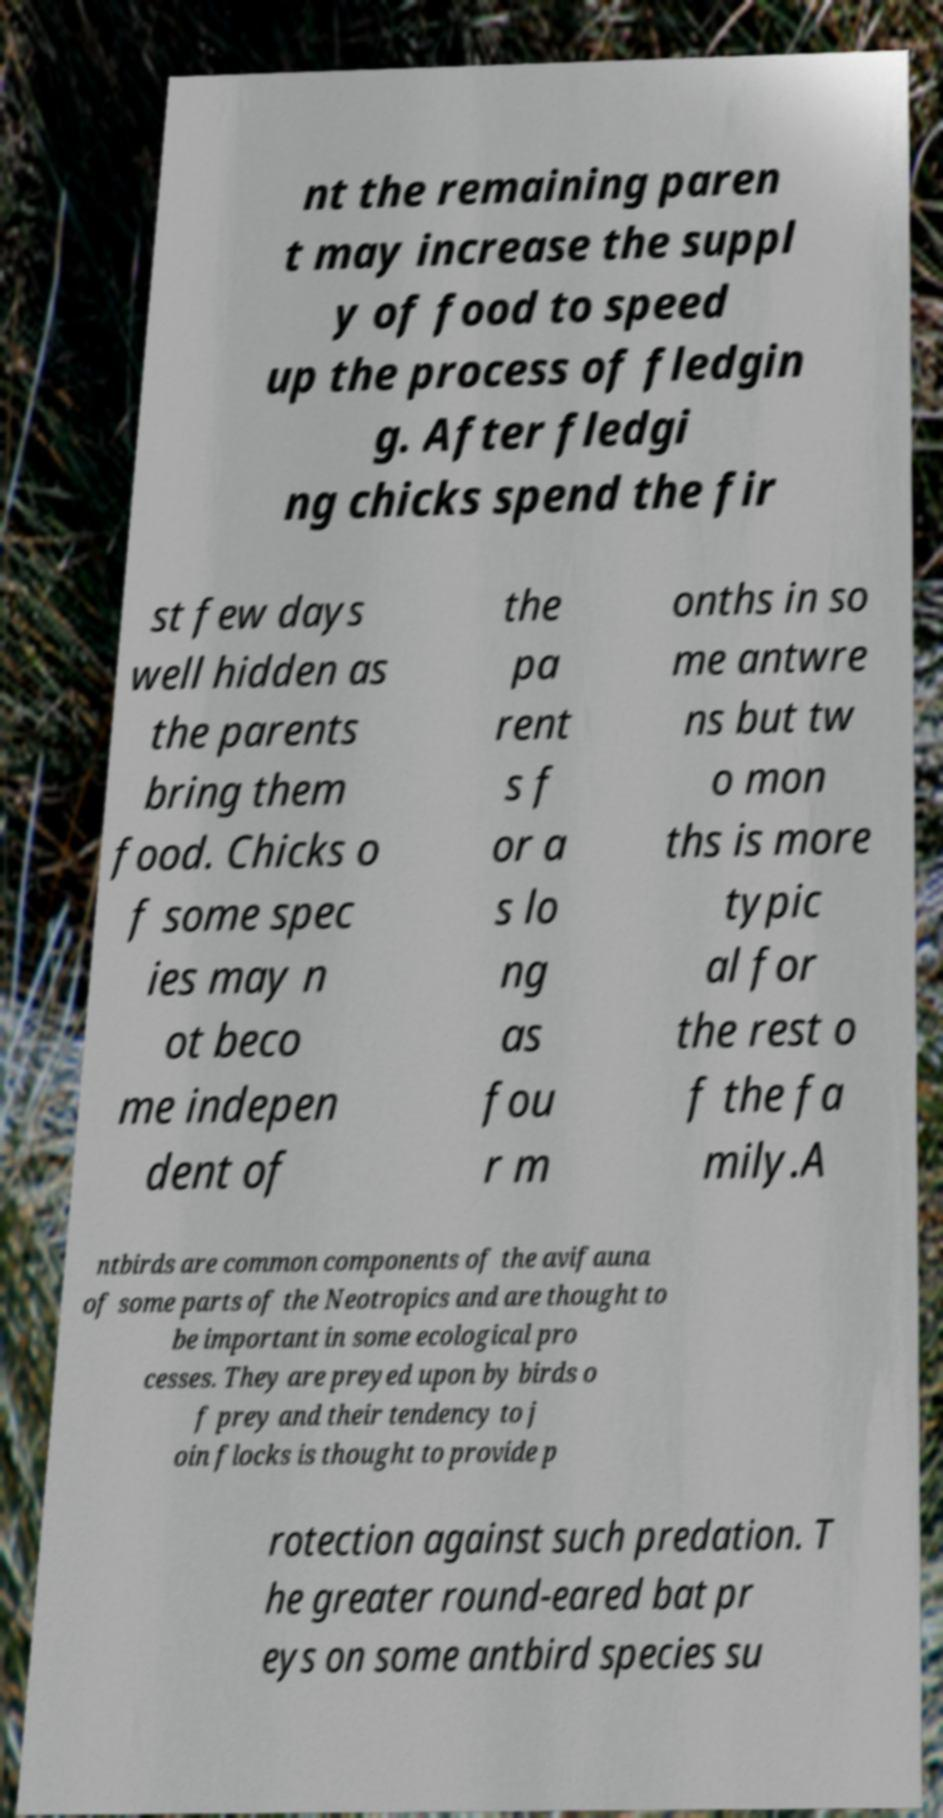Can you accurately transcribe the text from the provided image for me? nt the remaining paren t may increase the suppl y of food to speed up the process of fledgin g. After fledgi ng chicks spend the fir st few days well hidden as the parents bring them food. Chicks o f some spec ies may n ot beco me indepen dent of the pa rent s f or a s lo ng as fou r m onths in so me antwre ns but tw o mon ths is more typic al for the rest o f the fa mily.A ntbirds are common components of the avifauna of some parts of the Neotropics and are thought to be important in some ecological pro cesses. They are preyed upon by birds o f prey and their tendency to j oin flocks is thought to provide p rotection against such predation. T he greater round-eared bat pr eys on some antbird species su 